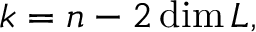<formula> <loc_0><loc_0><loc_500><loc_500>k = n - 2 \dim L ,</formula> 